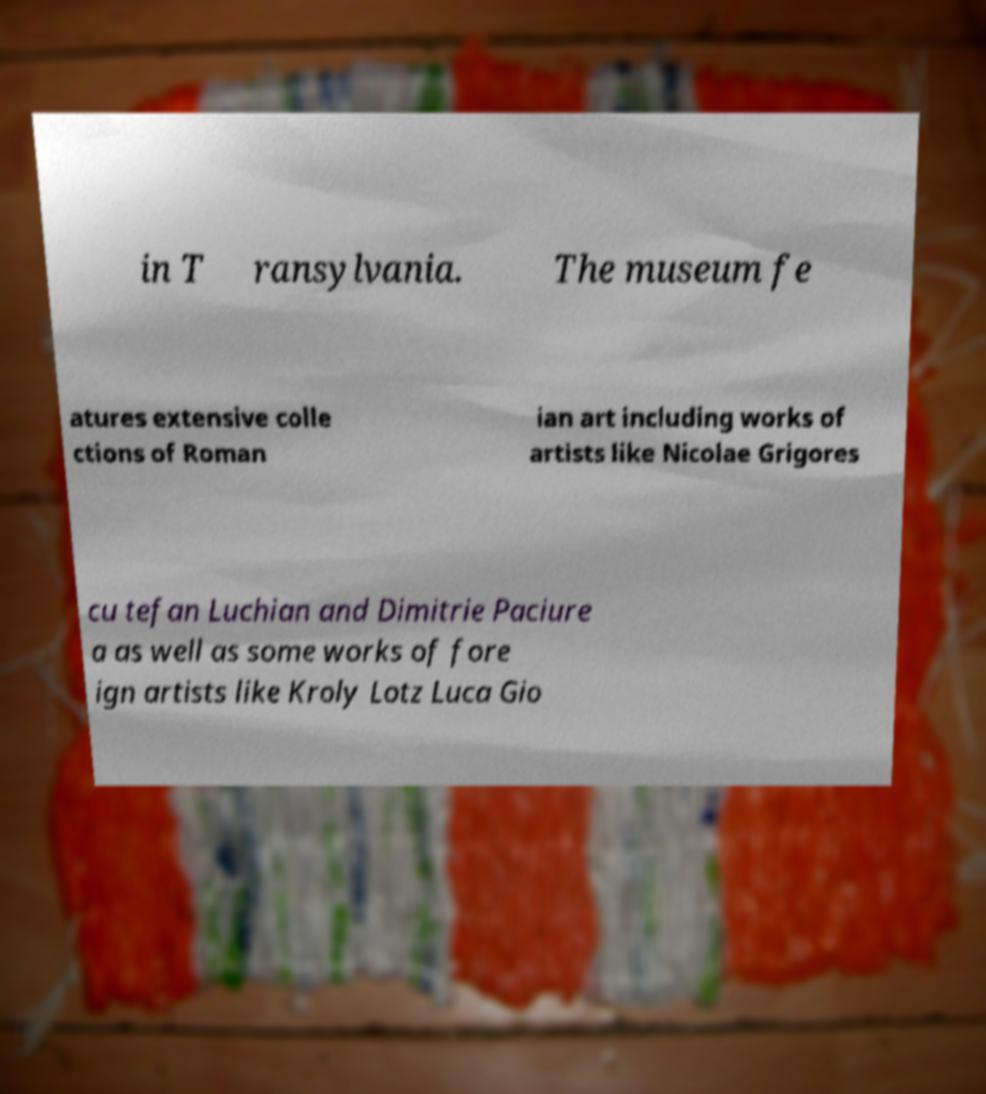Could you extract and type out the text from this image? in T ransylvania. The museum fe atures extensive colle ctions of Roman ian art including works of artists like Nicolae Grigores cu tefan Luchian and Dimitrie Paciure a as well as some works of fore ign artists like Kroly Lotz Luca Gio 